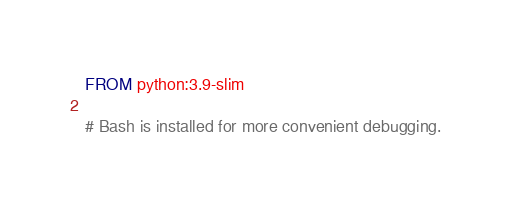Convert code to text. <code><loc_0><loc_0><loc_500><loc_500><_Dockerfile_>FROM python:3.9-slim

# Bash is installed for more convenient debugging.</code> 